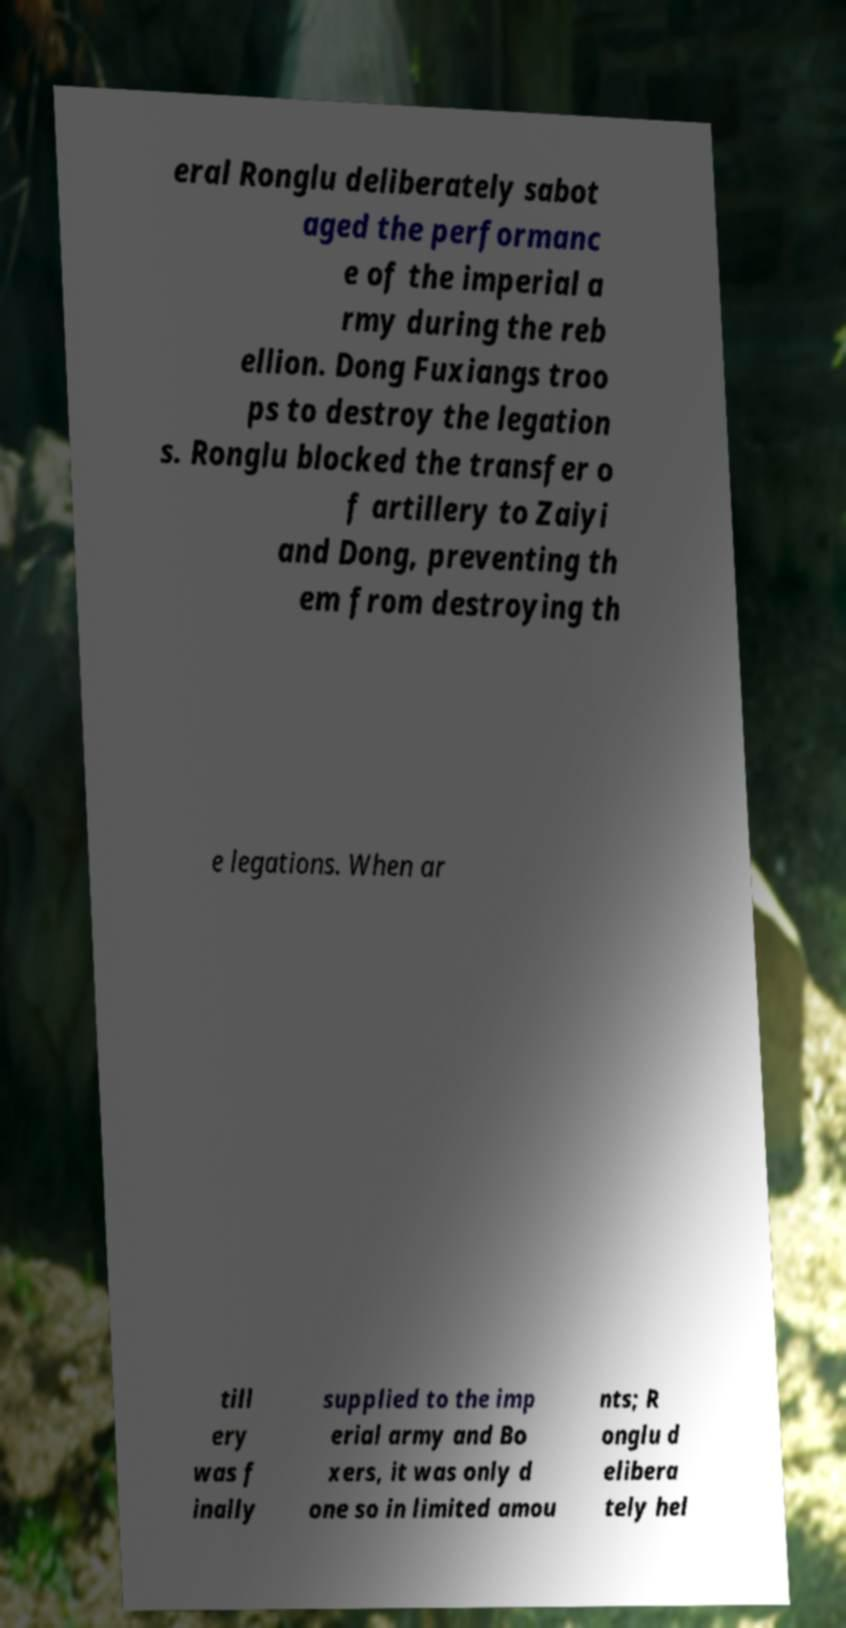Can you accurately transcribe the text from the provided image for me? eral Ronglu deliberately sabot aged the performanc e of the imperial a rmy during the reb ellion. Dong Fuxiangs troo ps to destroy the legation s. Ronglu blocked the transfer o f artillery to Zaiyi and Dong, preventing th em from destroying th e legations. When ar till ery was f inally supplied to the imp erial army and Bo xers, it was only d one so in limited amou nts; R onglu d elibera tely hel 